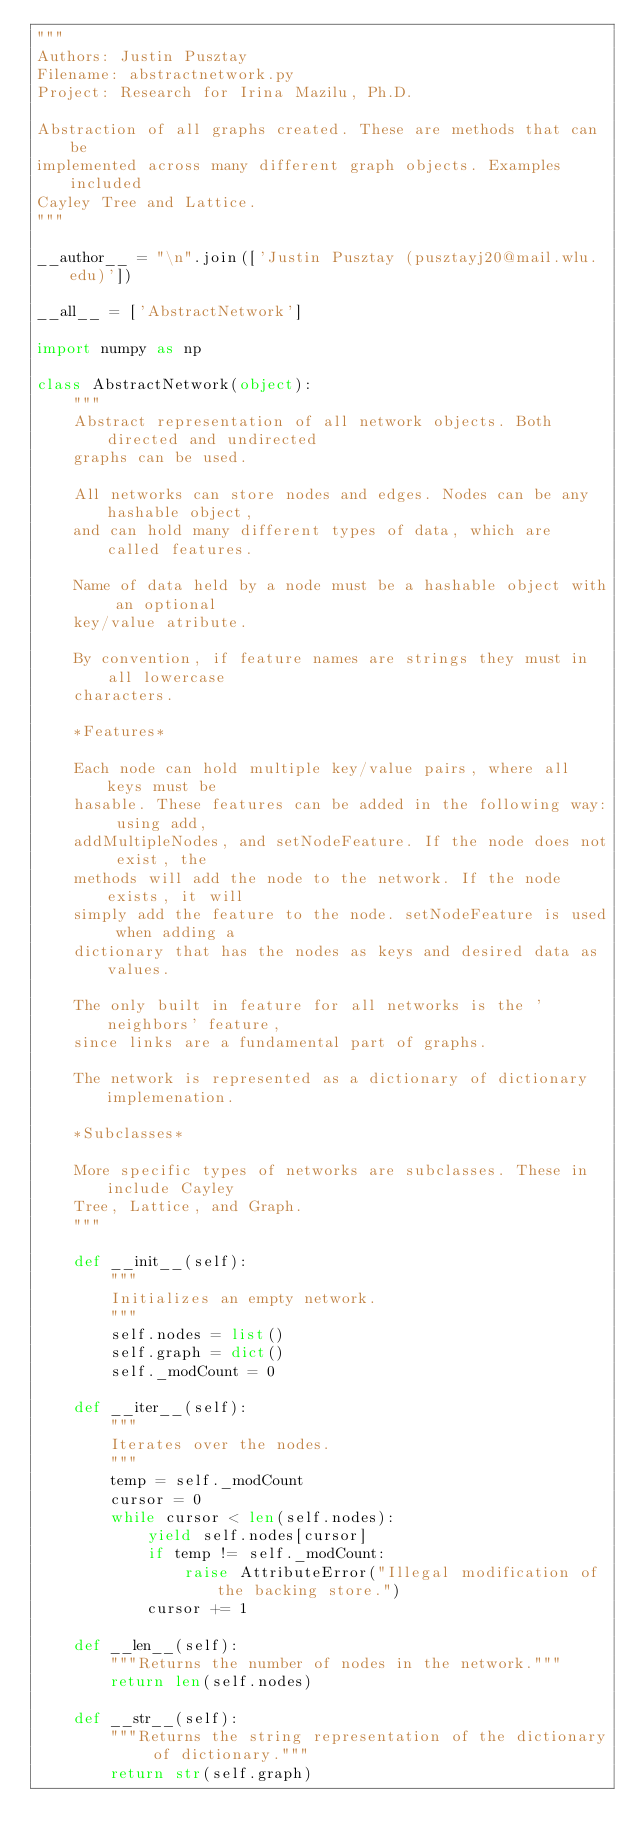Convert code to text. <code><loc_0><loc_0><loc_500><loc_500><_Python_>"""
Authors: Justin Pusztay
Filename: abstractnetwork.py
Project: Research for Irina Mazilu, Ph.D.

Abstraction of all graphs created. These are methods that can be
implemented across many different graph objects. Examples included
Cayley Tree and Lattice. 
"""

__author__ = "\n".join(['Justin Pusztay (pusztayj20@mail.wlu.edu)'])

__all__ = ['AbstractNetwork']

import numpy as np

class AbstractNetwork(object):
    """
    Abstract representation of all network objects. Both directed and undirected
    graphs can be used.

    All networks can store nodes and edges. Nodes can be any hashable object,
    and can hold many different types of data, which are called features.

    Name of data held by a node must be a hashable object with an optional
    key/value atribute.

    By convention, if feature names are strings they must in all lowercase
    characters. 

    *Features*

    Each node can hold multiple key/value pairs, where all keys must be
    hasable. These features can be added in the following way: using add,
    addMultipleNodes, and setNodeFeature. If the node does not exist, the
    methods will add the node to the network. If the node exists, it will
    simply add the feature to the node. setNodeFeature is used when adding a
    dictionary that has the nodes as keys and desired data as values.

    The only built in feature for all networks is the 'neighbors' feature,
    since links are a fundamental part of graphs. 

    The network is represented as a dictionary of dictionary implemenation.

    *Subclasses*

    More specific types of networks are subclasses. These in include Cayley
    Tree, Lattice, and Graph. 
    """

    def __init__(self):
        """
        Initializes an empty network. 
        """
        self.nodes = list()
        self.graph = dict()
        self._modCount = 0

    def __iter__(self):
        """
        Iterates over the nodes.
        """
        temp = self._modCount
        cursor = 0
        while cursor < len(self.nodes):
            yield self.nodes[cursor]
            if temp != self._modCount:
                raise AttributeError("Illegal modification of the backing store.")
            cursor += 1

    def __len__(self):
        """Returns the number of nodes in the network."""
        return len(self.nodes)

    def __str__(self):
        """Returns the string representation of the dictionary of dictionary."""
        return str(self.graph)
</code> 